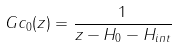Convert formula to latex. <formula><loc_0><loc_0><loc_500><loc_500>\ G c _ { 0 } ( z ) = \frac { 1 } { z - H _ { 0 } - H _ { i n t } }</formula> 